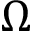<formula> <loc_0><loc_0><loc_500><loc_500>\Omega</formula> 